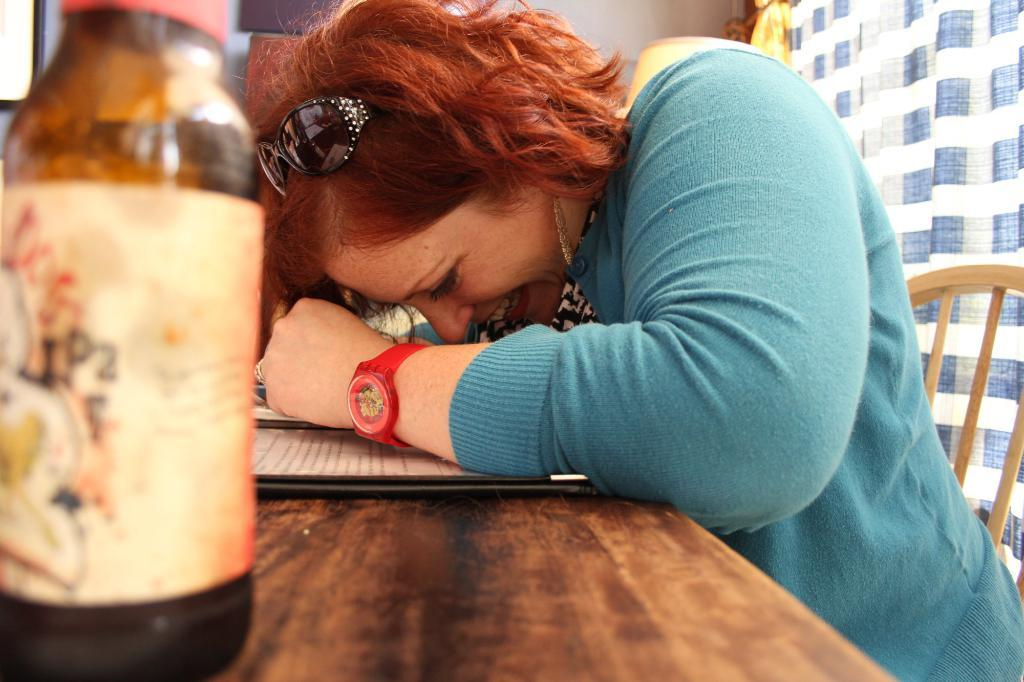Who is in the image? There is a person in the image. What is the person wearing? The person is wearing a blue dress, goggles, and a red wristwatch. What is the person doing in the image? The person is sitting on a chair. What else can be seen in the image? There is a bottle on the left side of the image. What type of guitar is the person playing in the image? There is no guitar present in the image; the person is wearing goggles and sitting on a chair. 